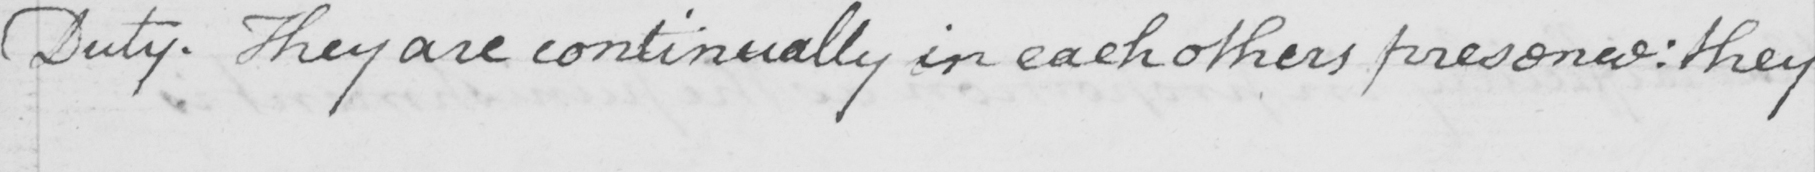Can you tell me what this handwritten text says? Duty . They are continually in each others presence :  they 